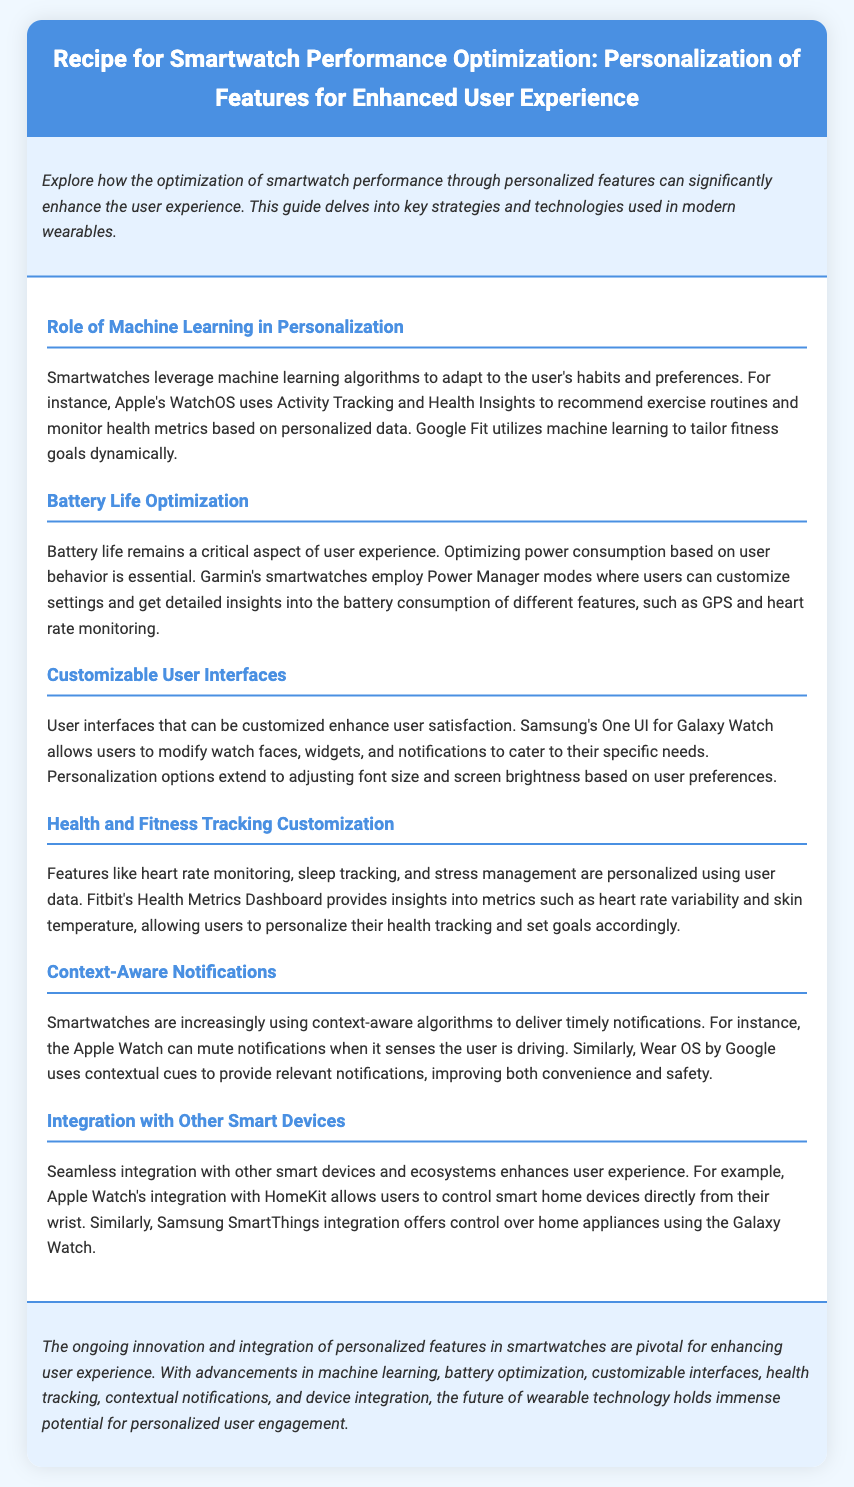What is the title of the recipe? The title is specifically mentioned in the document's header section.
Answer: Recipe for Smartwatch Performance Optimization: Personalization of Features for Enhanced User Experience Which company uses machine learning for health insights? The document names specific companies and their features, such as Apple's WatchOS and Google Fit.
Answer: Apple What feature does Garmin's smartwatches optimize? The document highlights battery life optimization as a critical aspect of user experience.
Answer: Battery life What user interface customization options are mentioned? The section on customizable user interfaces discusses various options available to users.
Answer: Watch faces, widgets, notifications Which smartwatch integrates with HomeKit? The document mentions specific integrations related to the ecosystems of different smartwatch brands.
Answer: Apple Watch What technology is used for context-aware notifications? Context-aware algorithms are mentioned as a technology being utilized for notifications on smartwatches.
Answer: Algorithms What aspect of user experience does the conclusion focus on? The conclusion summarizes the ongoing innovations in smartwatches and their importance regarding user engagement.
Answer: Personalized features Name one health metric tracked by Fitbit. The document discusses insights provided by Fitbit's Health Metrics Dashboard.
Answer: Heart rate variability How does Samsung Galaxy Watch enhance user experience? The document mentions specific integrations that enhance user experience through ecosystems.
Answer: SmartThings integration 